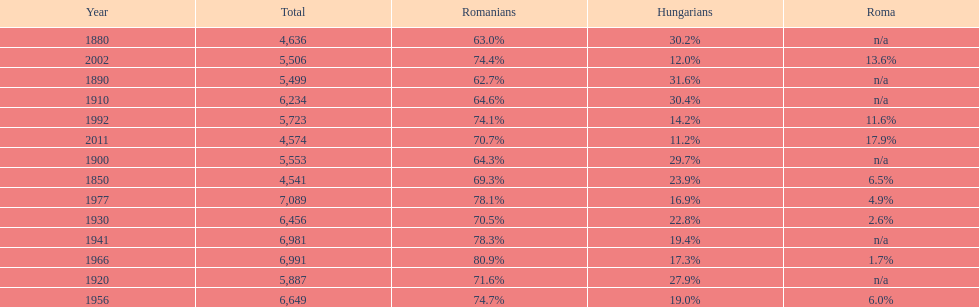In which year was the subsequent highest percentage for roma following 2011? 2002. 